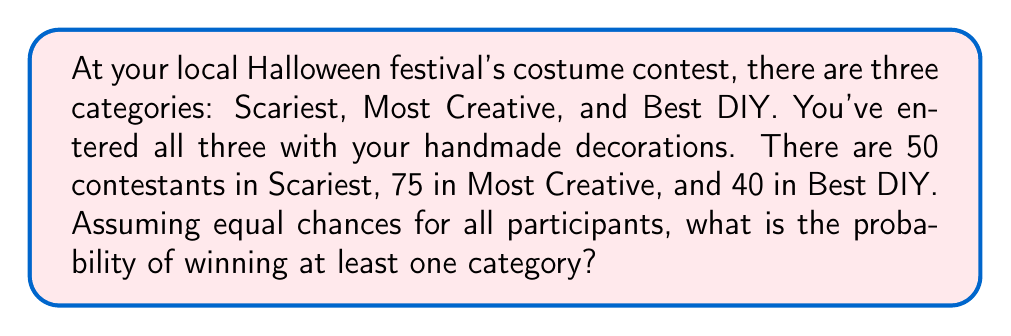Give your solution to this math problem. Let's approach this step-by-step:

1) First, let's calculate the probability of winning each category:
   
   Scariest: $P(S) = \frac{1}{50}$
   Most Creative: $P(C) = \frac{1}{75}$
   Best DIY: $P(D) = \frac{1}{40}$

2) Now, it's easier to calculate the probability of not winning any category:
   
   $P(\text{not winning}) = (1 - P(S)) \times (1 - P(C)) \times (1 - P(D))$

3) Substituting the values:

   $P(\text{not winning}) = (1 - \frac{1}{50}) \times (1 - \frac{1}{75}) \times (1 - \frac{1}{40})$

4) Simplifying:

   $P(\text{not winning}) = \frac{49}{50} \times \frac{74}{75} \times \frac{39}{40}$

5) Calculating:

   $P(\text{not winning}) = 0.9498$

6) Therefore, the probability of winning at least one category is:

   $P(\text{winning at least one}) = 1 - P(\text{not winning})$
   $= 1 - 0.9498 = 0.0502$
Answer: $0.0502$ or $5.02\%$ 